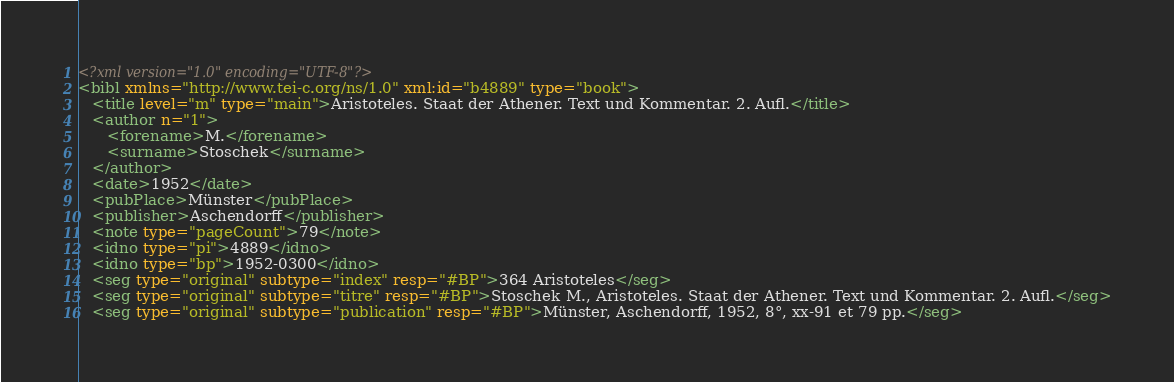Convert code to text. <code><loc_0><loc_0><loc_500><loc_500><_XML_><?xml version="1.0" encoding="UTF-8"?>
<bibl xmlns="http://www.tei-c.org/ns/1.0" xml:id="b4889" type="book">
   <title level="m" type="main">Aristoteles. Staat der Athener. Text und Kommentar. 2. Aufl.</title>
   <author n="1">
      <forename>M.</forename>
      <surname>Stoschek</surname>
   </author>
   <date>1952</date>
   <pubPlace>Münster</pubPlace>
   <publisher>Aschendorff</publisher>
   <note type="pageCount">79</note>
   <idno type="pi">4889</idno>
   <idno type="bp">1952-0300</idno>
   <seg type="original" subtype="index" resp="#BP">364 Aristoteles</seg>
   <seg type="original" subtype="titre" resp="#BP">Stoschek M., Aristoteles. Staat der Athener. Text und Kommentar. 2. Aufl.</seg>
   <seg type="original" subtype="publication" resp="#BP">Münster, Aschendorff, 1952, 8°, xx-91 et 79 pp.</seg></code> 